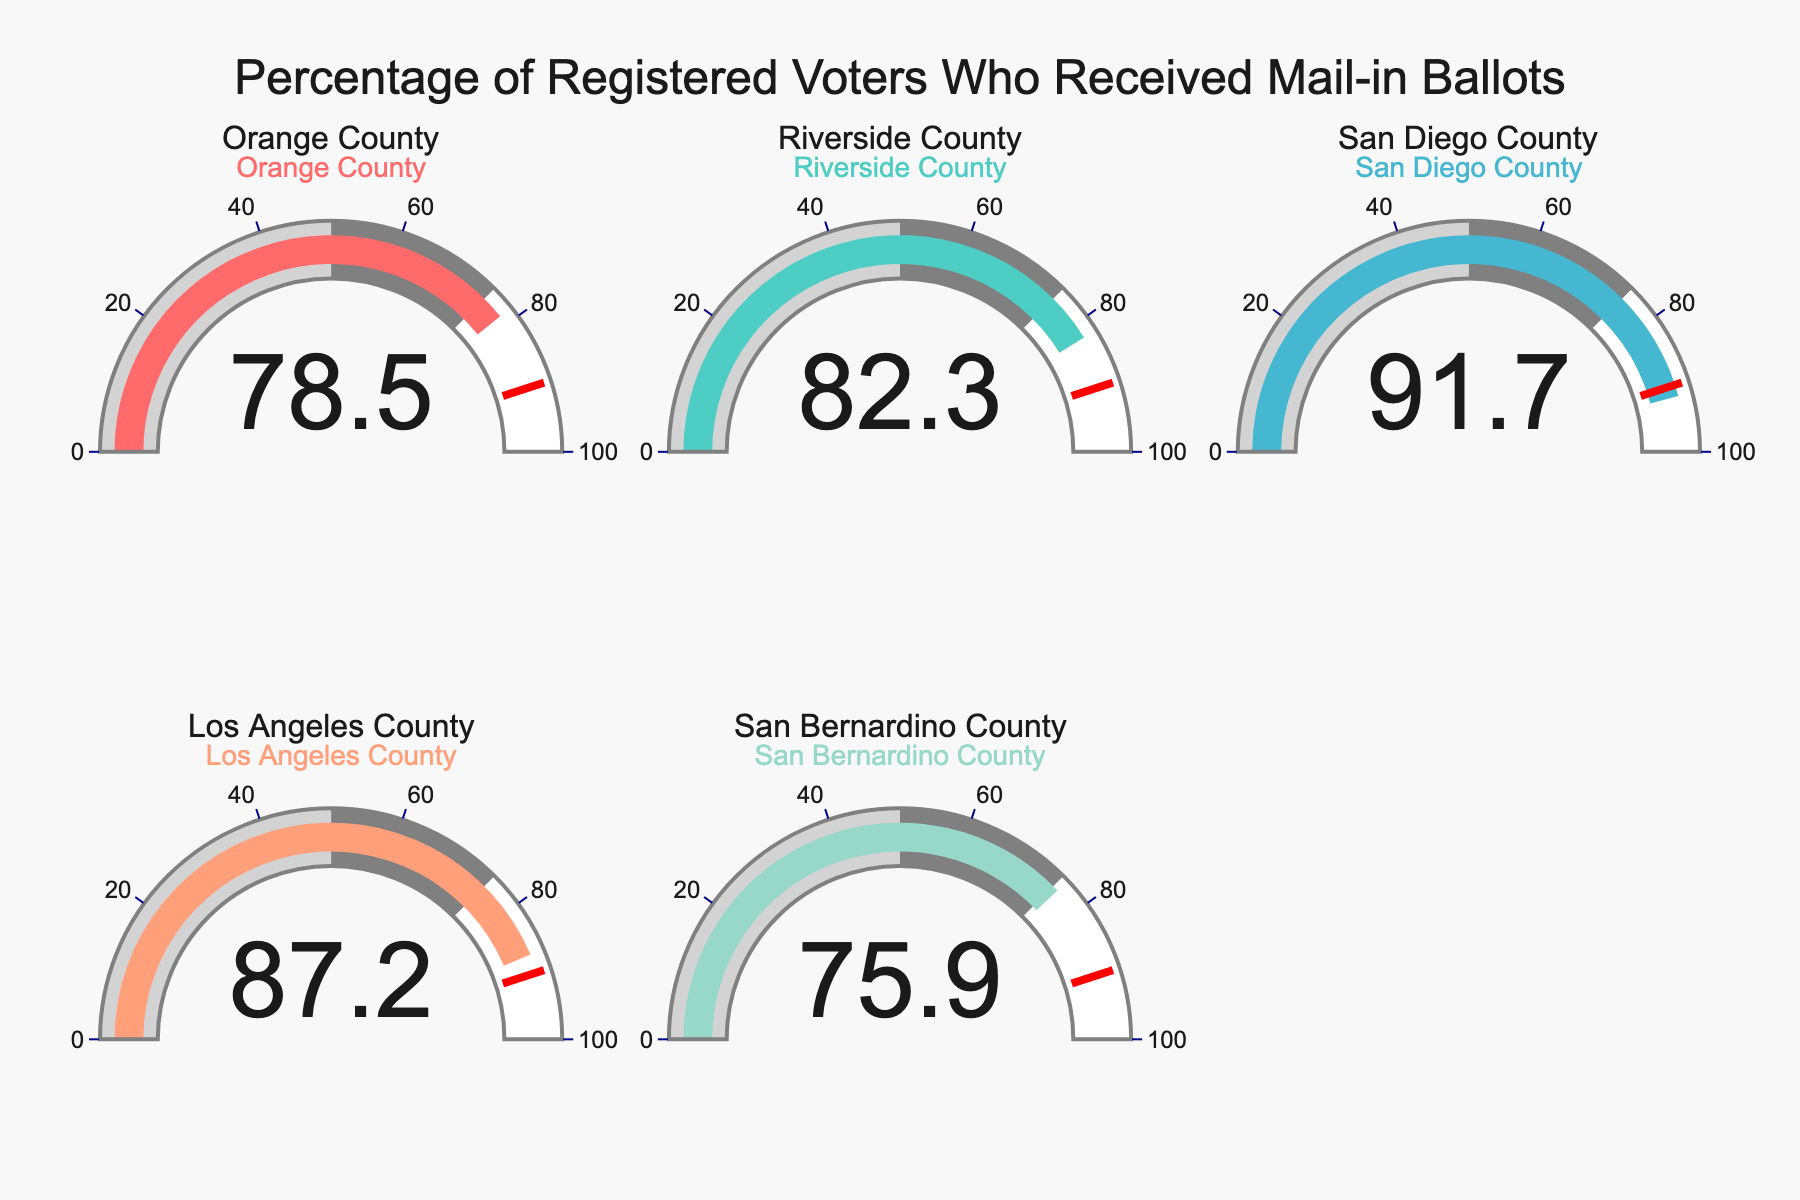what percentage of registered voters in Orange County received mail-in ballots? The gauge for Orange County shows 78.5% on the figure, indicating this is the percentage of registered voters who received mail-in ballots.
Answer: 78.5% which county has the highest percentage of mail-in ballots received by registered voters? The gauge for San Diego County shows 91.7%, which is the highest value among all counties presented.
Answer: San Diego County which county has a percentage of mail-in ballots received that is closest to 80%? Orange County has a percentage of 78.5%, which is the closest to 80% among the data points.
Answer: Orange County what is the average percentage of registered voters receiving mail-in ballots across all counties? The percentages are 78.5%, 82.3%, 91.7%, 87.2%, and 75.9%. Adding these up gives 415.6, and dividing by 5 results in: 415.6/5 = 83.12.
Answer: 83.12% are there any counties where the percentage of mail-in ballots received falls below 80%? Yes, the gauges for Orange County (78.5%) and San Bernardino County (75.9%) both show values below 80%.
Answer: Yes how much higher is the percentage of San Diego County compared to San Bernardino County? The percentage for San Diego County is 91.7%, while for San Bernardino County it is 75.9%. The difference is 91.7 - 75.9 = 15.8%.
Answer: 15.8% how many counties have more than 85% of registered voters receiving mail-in ballots? By examining the gauges, we see that Riverside County (82.3%), Los Angeles County (87.2%), and San Diego County (91.7%) are above 85%. That makes a total of 2 counties.
Answer: 2 is any county very close to the threshold value of 90% as indicated in the chart? Yes, Los Angeles County has 87.2%, which is close but still less than the 90% threshold.
Answer: Yes do more counties have percentages greater than or equal to 85% or less than 85%? Percentages greater than or equal to 85% are Los Angeles County (87.2%) and San Diego County (91.7%). Percentages less than 85% are Orange County (78.5%), Riverside County (82.3%), and San Bernardino County (75.9%). Thus, more counties have less than 85%.
Answer: Less than 85% 